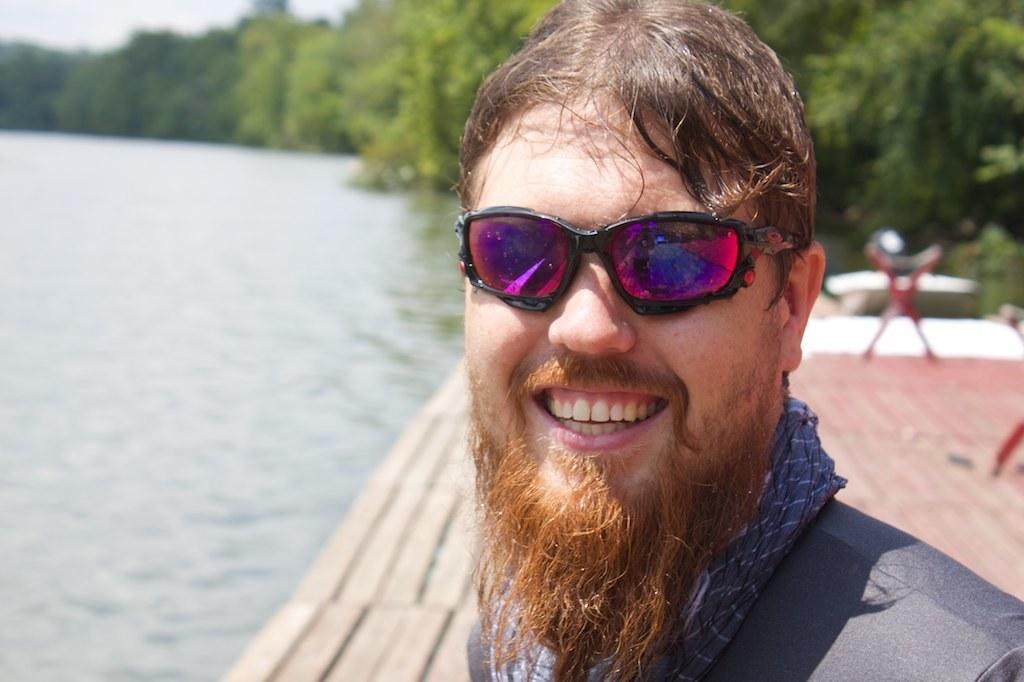Who or what is present in the image? There is a person in the image. What is the person wearing? The person is wearing a grey dress and glasses. What can be seen in the background of the image? Trees and water are visible in the background of the image. How is the background of the image depicted? The background is blurred. What type of bell can be heard ringing in the image? There is no bell present or audible in the image. What is the person offering to others in the image? The image does not depict the person offering anything to others. 